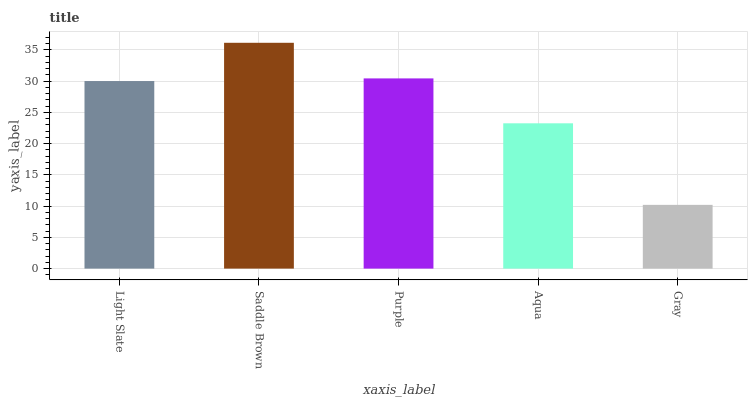Is Gray the minimum?
Answer yes or no. Yes. Is Saddle Brown the maximum?
Answer yes or no. Yes. Is Purple the minimum?
Answer yes or no. No. Is Purple the maximum?
Answer yes or no. No. Is Saddle Brown greater than Purple?
Answer yes or no. Yes. Is Purple less than Saddle Brown?
Answer yes or no. Yes. Is Purple greater than Saddle Brown?
Answer yes or no. No. Is Saddle Brown less than Purple?
Answer yes or no. No. Is Light Slate the high median?
Answer yes or no. Yes. Is Light Slate the low median?
Answer yes or no. Yes. Is Gray the high median?
Answer yes or no. No. Is Aqua the low median?
Answer yes or no. No. 